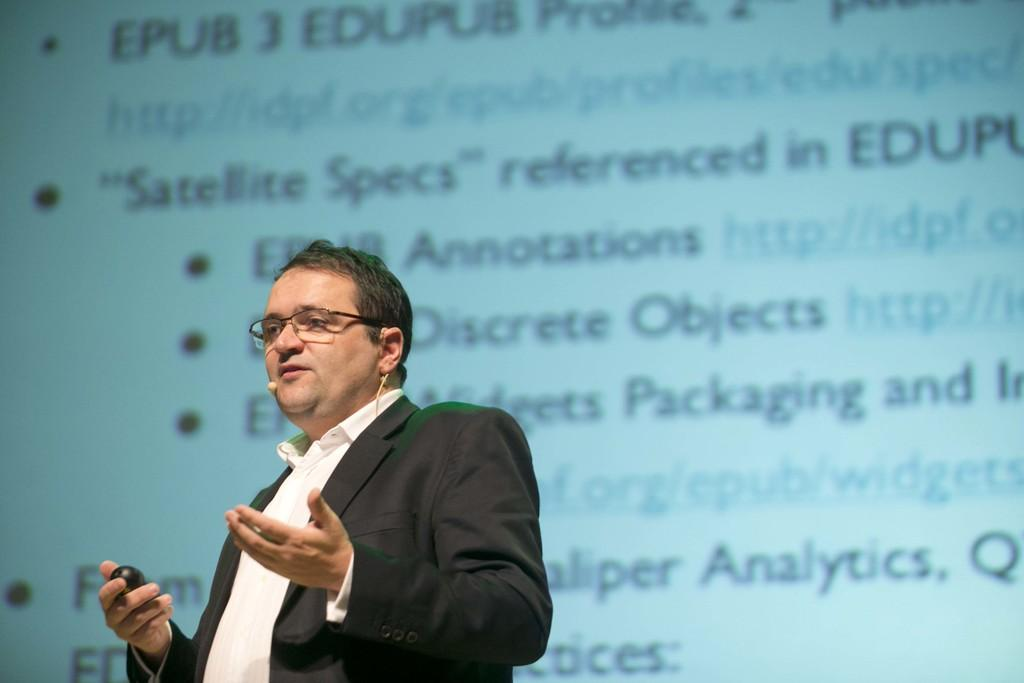What is the man in the image doing? The man is standing in the image. What is the man wearing? The man is wearing a shirt and a suit. What accessory is the man wearing? The man is wearing spectacles. What is the man holding in his hand? The man is holding an object in his hand. What can be seen in the background of the image? There is a screen with a display in the background of the image. What type of toys can be seen on fire in the image? There are no toys or flames present in the image. 